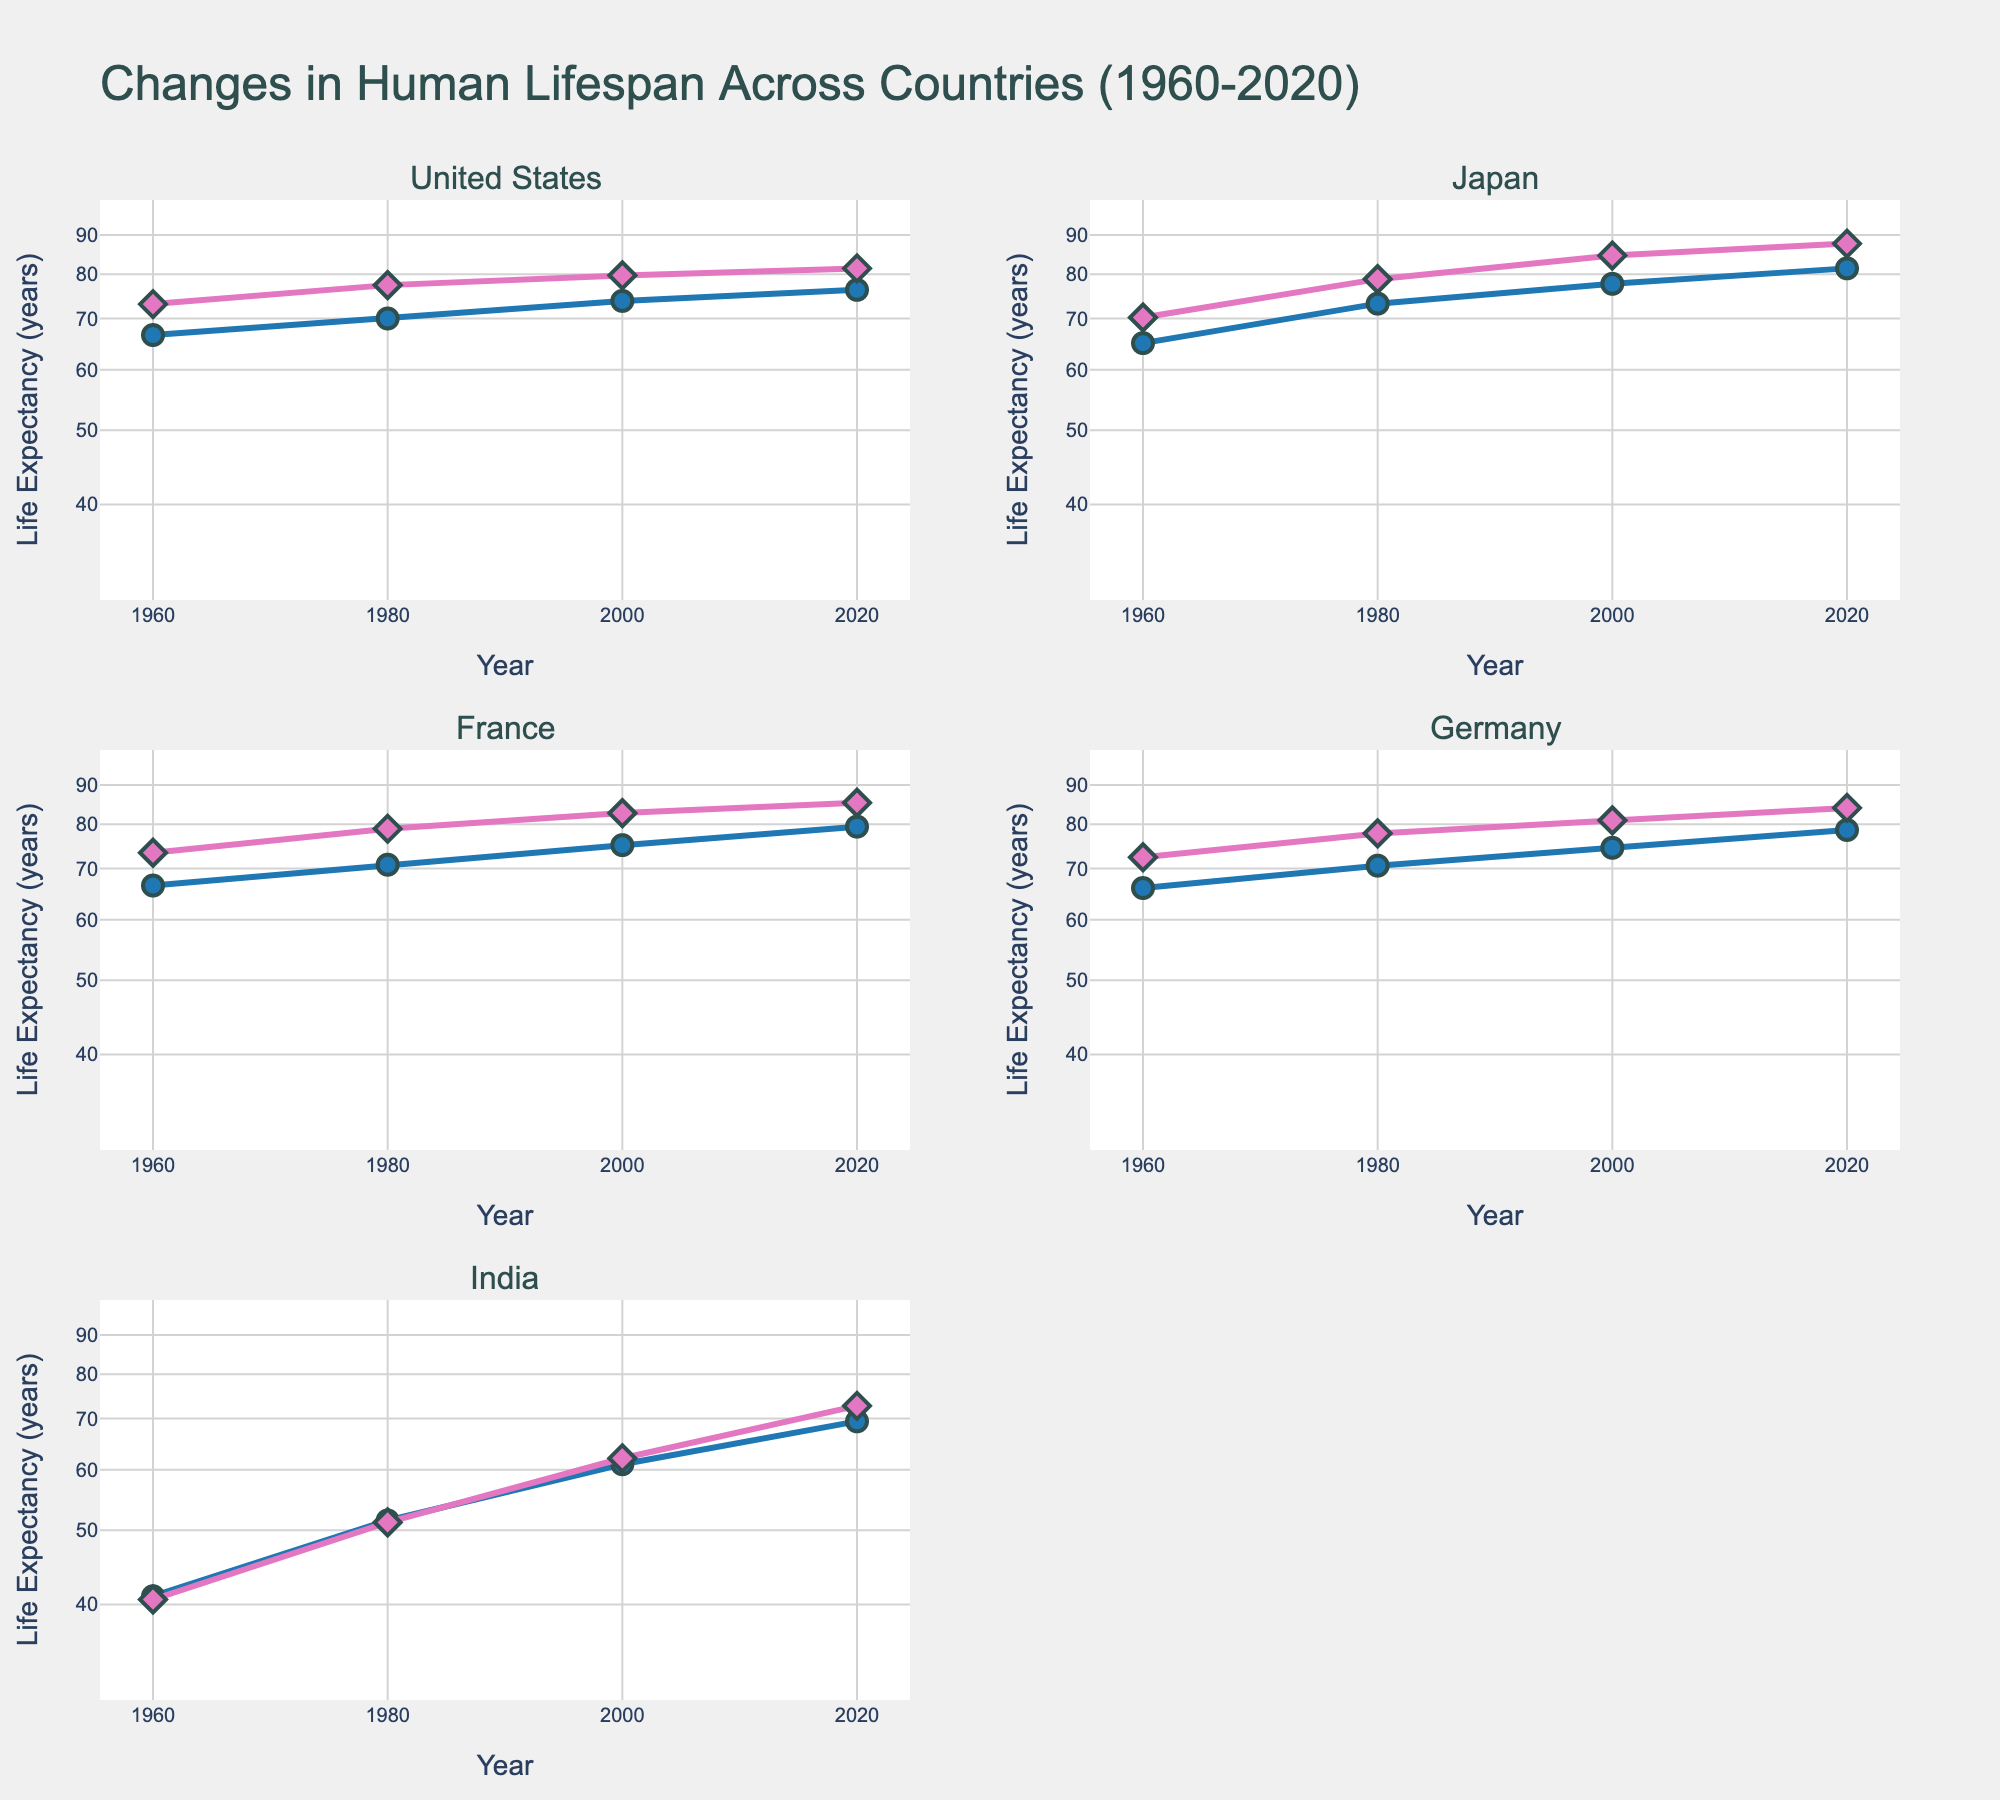What's the difference in life expectancy between males and females in the United States in 2020? Find the life expectancy values for males and females in the United States in 2020. The values are 76.3 for males and 81.4 for females. Subtract the male value from the female value: 81.4 - 76.3 = 5.1.
Answer: 5.1 Which country had the highest life expectancy for males in 2000? Locate the life expectancy values for males in 2000 for each country and compare them. Japan has the highest value of 77.7 for males in 2000.
Answer: Japan How has the life expectancy of females in India changed from 1960 to 2020? Find the life expectancy values for females in India for 1960 and 2020. The values are 40.6 in 1960 and 72.7 in 2020. Subtract the 1960 value from the 2020 value: 72.7 - 40.6 = 32.1.
Answer: Increased by 32.1 Which country shows the smallest gender gap in life expectancy in 2020? Find the life expectancy values for both genders in each country for 2020. Subtract the male value from the female value for each country. The smallest difference is found in Japan, with a difference of 6.3 (87.7 - 81.4).
Answer: Japan What is the log scale range used for the y-axis? Observe the minimum and maximum values on the y-axis which are shown as log scale, ranging from log(30) to log(100). In decimal, log(30) is approximately 1.48 and log(100) is 2.00.
Answer: From log(30) to log(100) Between 1960 and 2020, which country had the greatest increase in life expectancy for males? Calculate the increase in life expectancy for males in each country between 1960 and 2020 by subtracting the 1960 value from the 2020 value. India had the greatest increase: 69.4 - 41.0 = 28.4.
Answer: India In what year did France's female life expectancy cross 80 years? Examine the life expectancy values for females in France across different years. In 2000, the life expectancy for females reached 82.7, which is the first year it crossed 80.
Answer: 2000 Comparing all the countries, in which year did Japan achieve the highest life expectancy for females? Look for the highest life expectancy value for females in Japan across all years. The highest value is 87.7, which was achieved in 2020.
Answer: 2020 What is the trend in life expectancy for males in Germany from 1960 to 2020? Identify the life expectancy values for males in Germany for the years 1960 (66.0), 1980 (70.6), 2000 (74.5), and 2020 (78.6). Observe that the values show a consistently increasing trend.
Answer: Increasing trend 